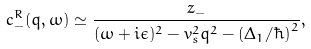Convert formula to latex. <formula><loc_0><loc_0><loc_500><loc_500>c ^ { R } _ { - } ( q , \omega ) \simeq \frac { z _ { - } } { ( \omega + i \epsilon ) ^ { 2 } - v _ { s } ^ { 2 } q ^ { 2 } - ( \Delta _ { 1 } / \hbar { ) } ^ { 2 } } ,</formula> 